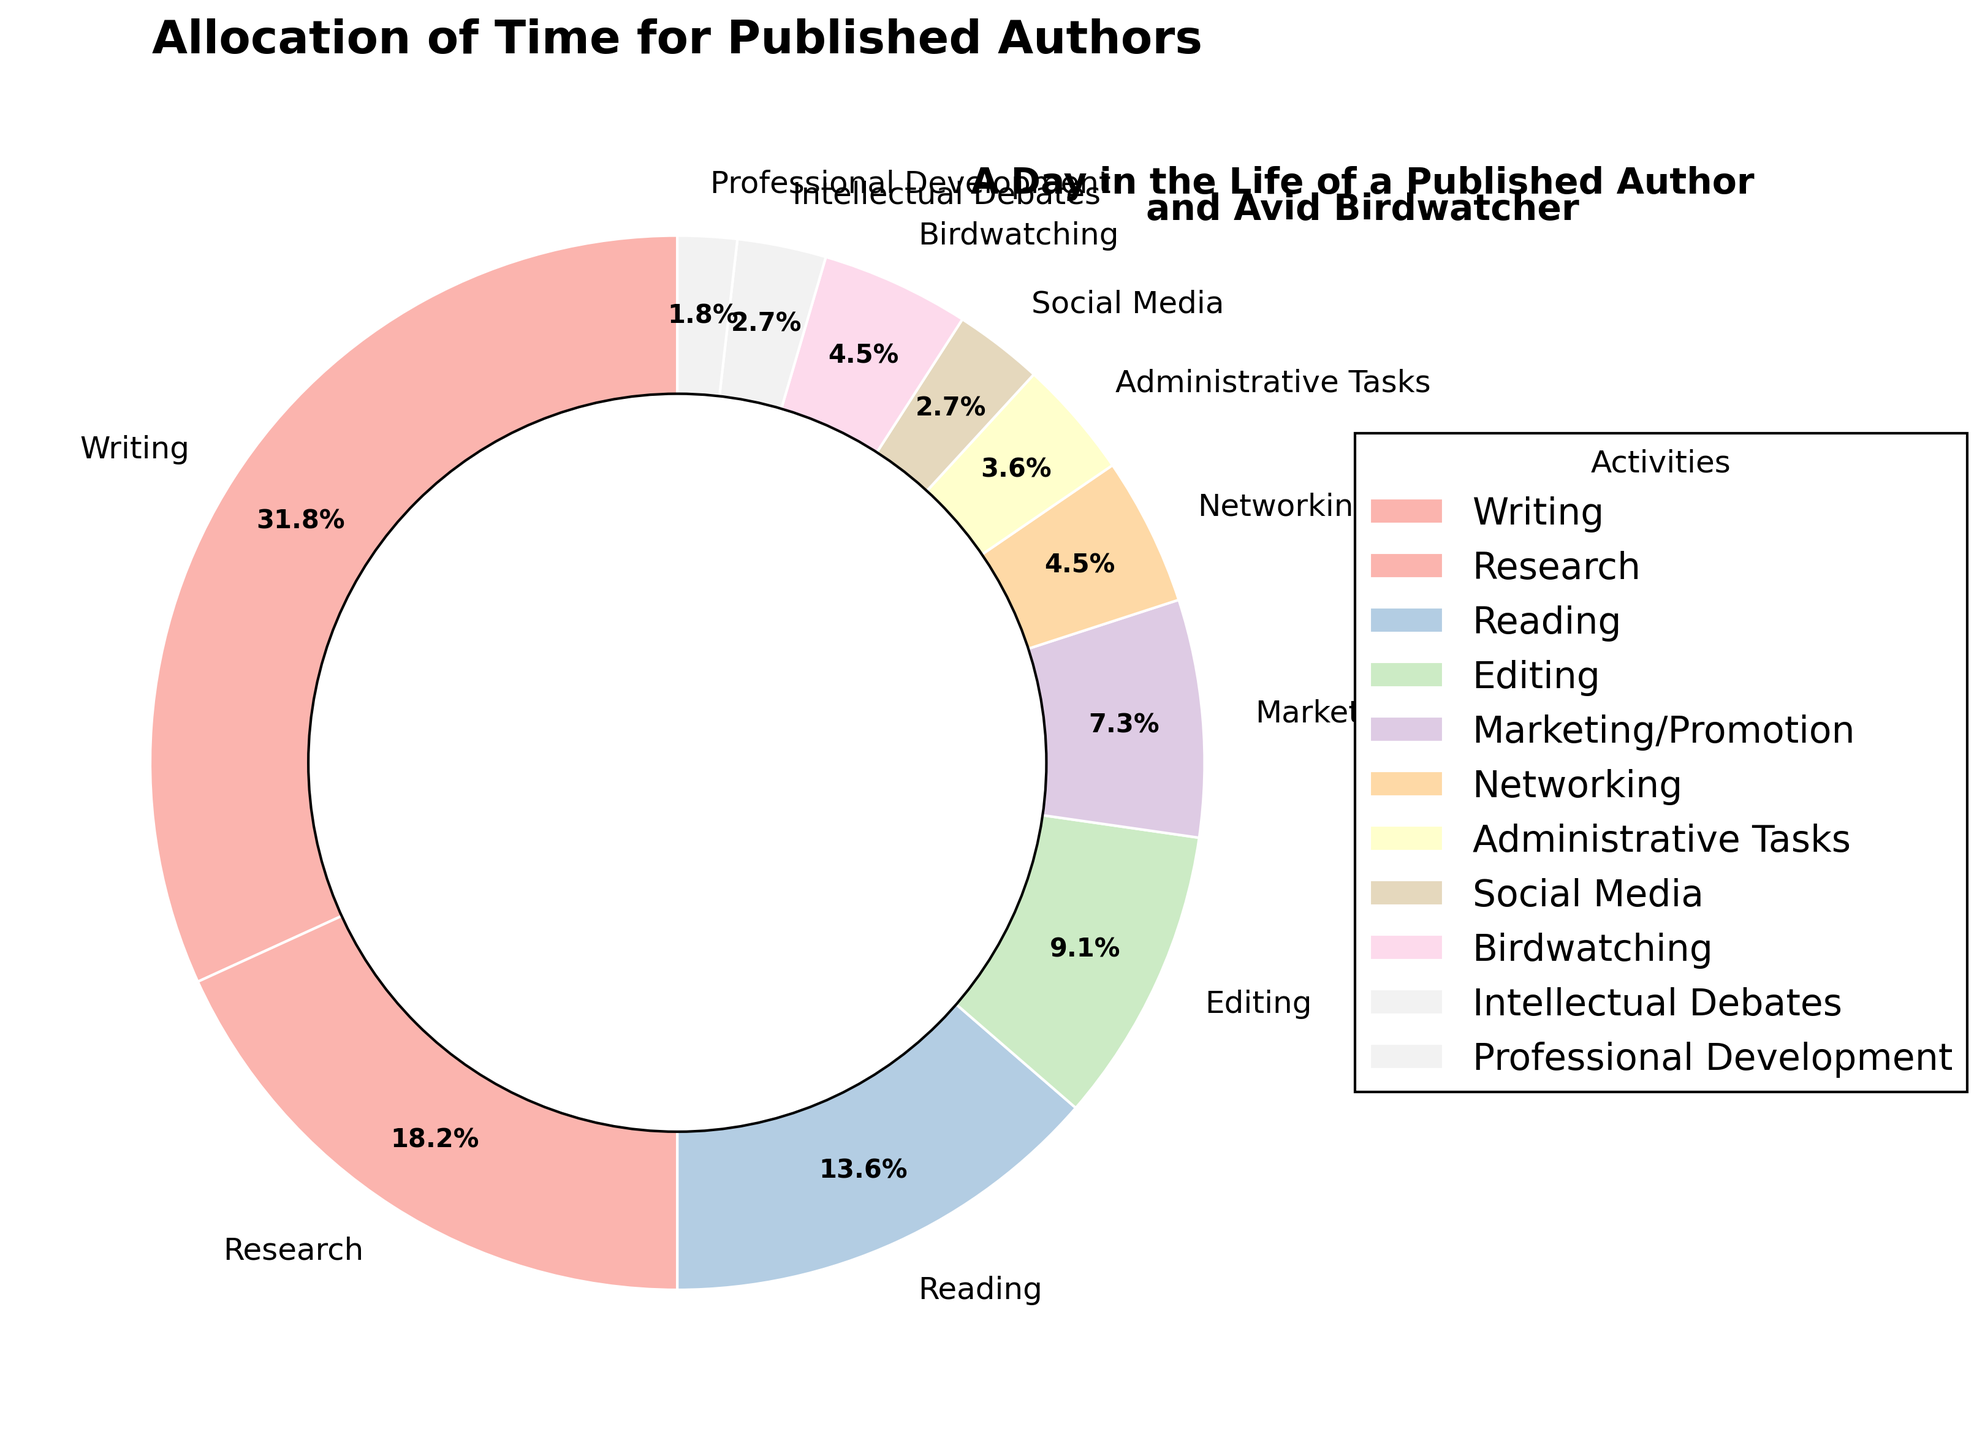Which activity takes up the largest portion of a published author's time? Referring to the pie chart, Writing takes up 35% of the total time, which is the largest portion compared to other activities.
Answer: Writing What is the combined percentage of time spent on Research and Professional Development? Research takes up 20% and Professional Development takes up 2%. Adding these together gives 22%.
Answer: 22% Is more time spent on Reading or Editing? Referring to the pie chart, Reading takes up 15% while Editing takes up 10%. Therefore, more time is spent on Reading.
Answer: Reading How much more time is spent on Writing compared to Marketing/Promotion? Writing takes up 35% and Marketing/Promotion takes up 8%. The difference is 35% - 8% = 27%.
Answer: 27% What fraction of the total time is spent on Birdwatching? Birdwatching takes up 5% of the time. In fraction form, this is 5/100 = 1/20.
Answer: 1/20 Between Networking and Intellectual Debates, which activity has a lesser percentage of time allocation? Networking takes up 5% while Intellectual Debates take up 3%. Thus, Intellectual Debates have a lesser percentage.
Answer: Intellectual Debates What is the total percentage of time allocated to activities related to writing and editing (i.e., Writing, Editing, and Reading)? Writing takes up 35%, Editing takes up 10%, and Reading takes up 15%. Summing these values gives 35% + 10% + 15% = 60%.
Answer: 60% What is the difference in time allocation between the least and the most time-consuming activities? The least time-consuming activity is Professional Development at 2%, and the most time-consuming activity is Writing at 35%. The difference is 35% - 2% = 33%.
Answer: 33% How does the percentage of time spent on Administrative Tasks compare to Social Media? Administrative Tasks take up 4% of the time, while Social Media takes up 3%. Administrative Tasks have a higher percentage by 1%.
Answer: Administrative Tasks have 1% more Which three activities cumulatively take up the smallest percentage of the total time? Referring to the pie chart, the three activities with the smallest percentages are Professional Development (2%), Social Media (3%), and Intellectual Debates (3%). Cumulatively, these take up 2% + 3% + 3% = 8%.
Answer: Professional Development, Social Media, Intellectual Debates 